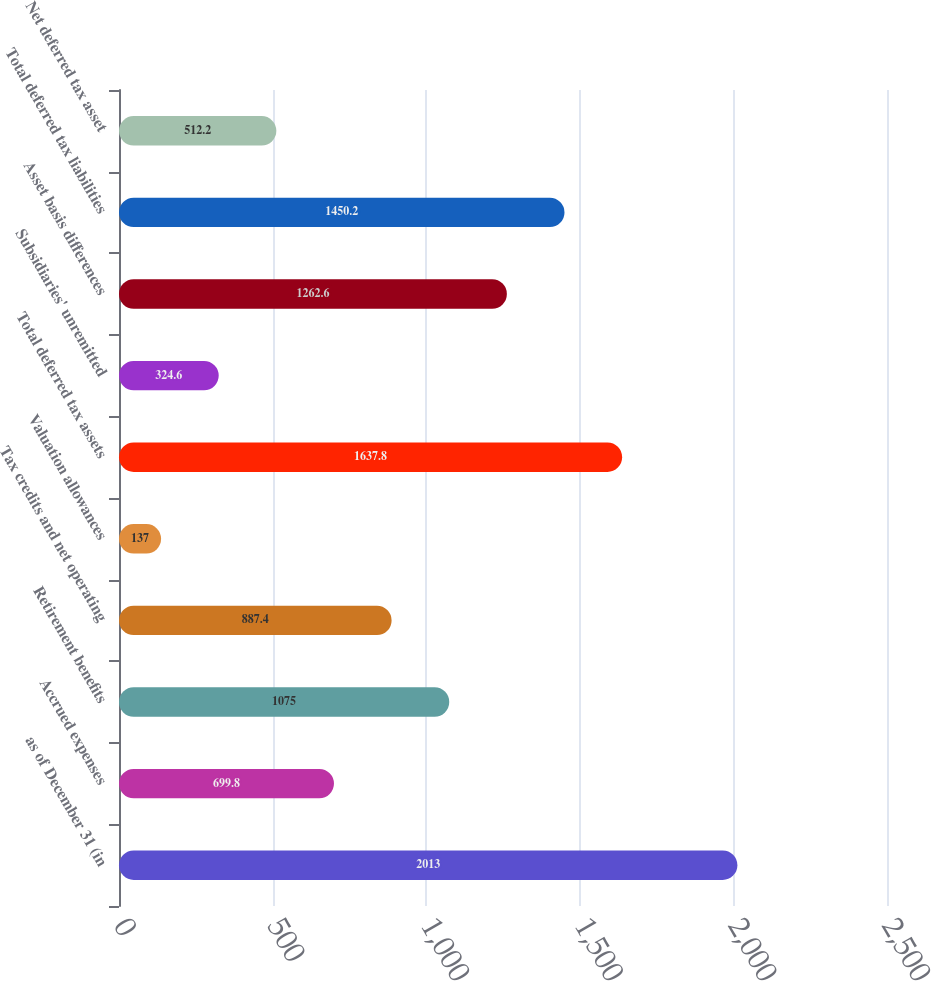Convert chart. <chart><loc_0><loc_0><loc_500><loc_500><bar_chart><fcel>as of December 31 (in<fcel>Accrued expenses<fcel>Retirement benefits<fcel>Tax credits and net operating<fcel>Valuation allowances<fcel>Total deferred tax assets<fcel>Subsidiaries' unremitted<fcel>Asset basis differences<fcel>Total deferred tax liabilities<fcel>Net deferred tax asset<nl><fcel>2013<fcel>699.8<fcel>1075<fcel>887.4<fcel>137<fcel>1637.8<fcel>324.6<fcel>1262.6<fcel>1450.2<fcel>512.2<nl></chart> 